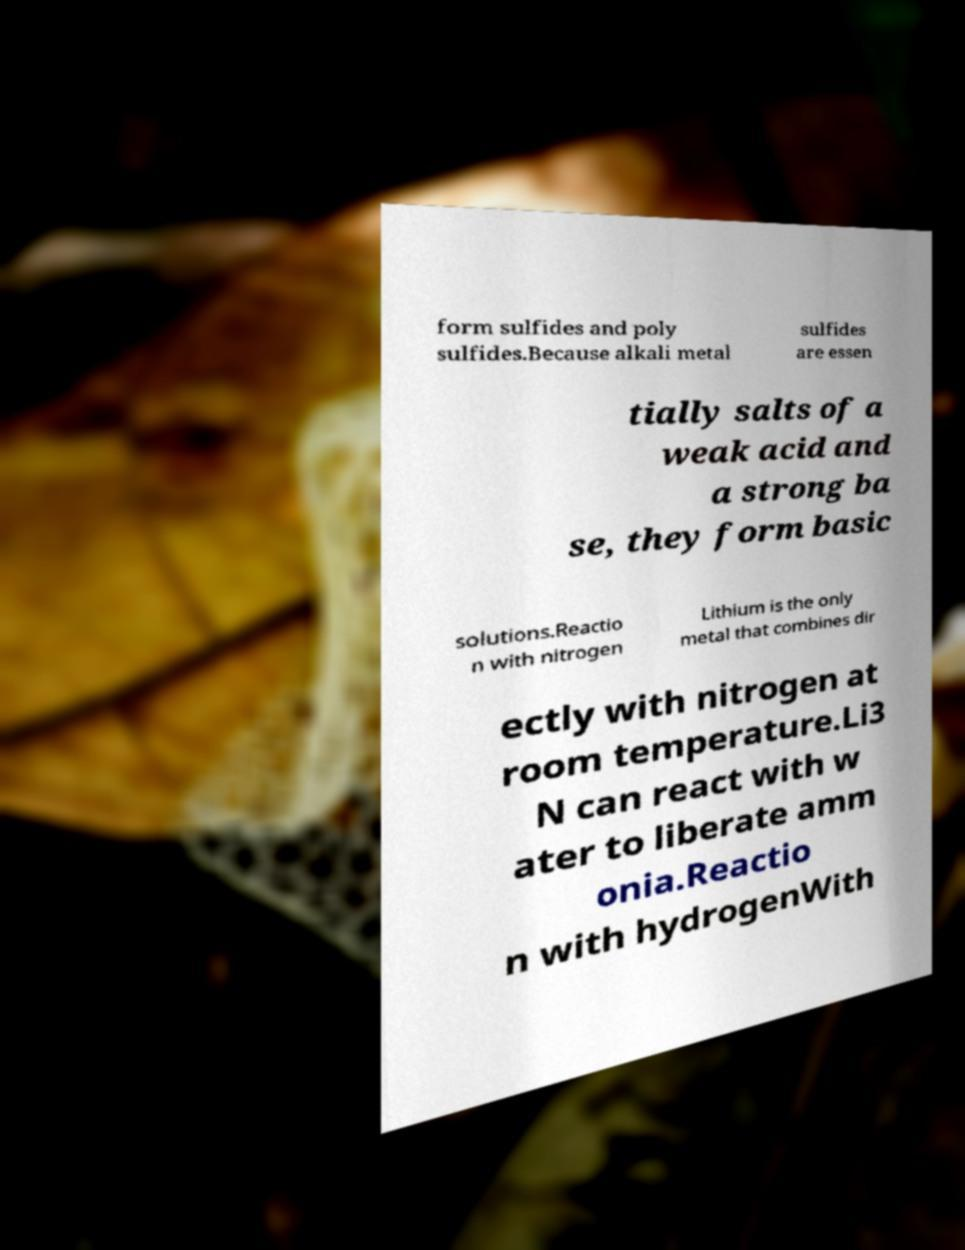Can you accurately transcribe the text from the provided image for me? form sulfides and poly sulfides.Because alkali metal sulfides are essen tially salts of a weak acid and a strong ba se, they form basic solutions.Reactio n with nitrogen Lithium is the only metal that combines dir ectly with nitrogen at room temperature.Li3 N can react with w ater to liberate amm onia.Reactio n with hydrogenWith 